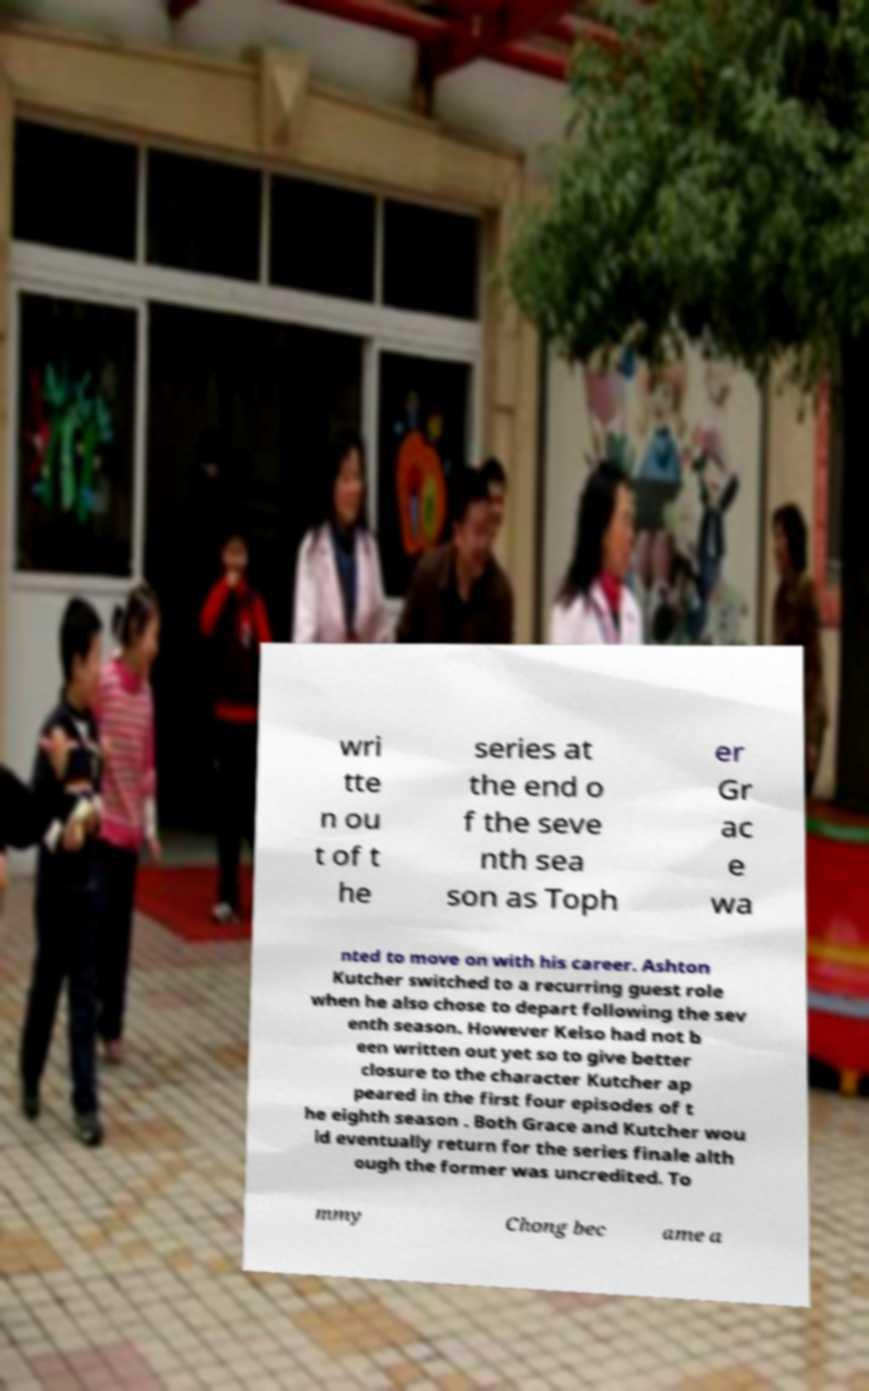For documentation purposes, I need the text within this image transcribed. Could you provide that? wri tte n ou t of t he series at the end o f the seve nth sea son as Toph er Gr ac e wa nted to move on with his career. Ashton Kutcher switched to a recurring guest role when he also chose to depart following the sev enth season. However Kelso had not b een written out yet so to give better closure to the character Kutcher ap peared in the first four episodes of t he eighth season . Both Grace and Kutcher wou ld eventually return for the series finale alth ough the former was uncredited. To mmy Chong bec ame a 